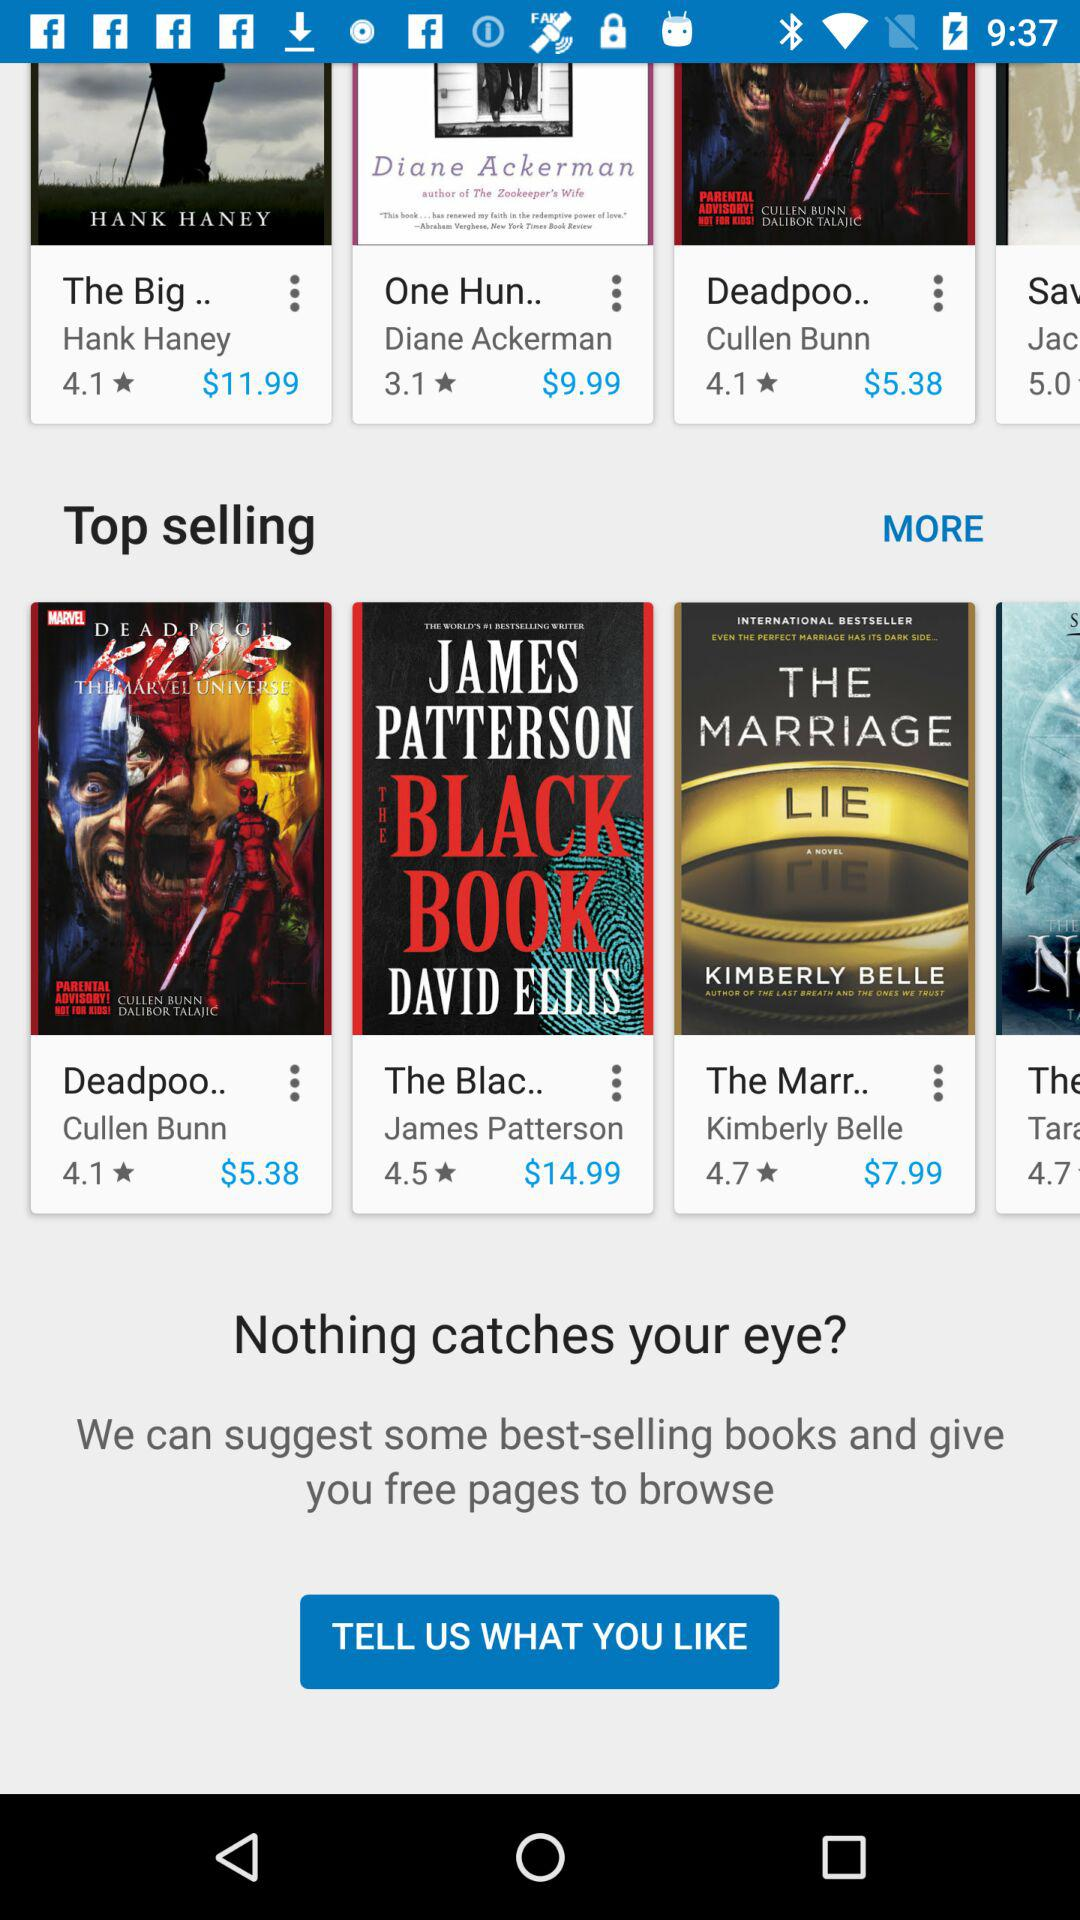What is the star rating of the book "The Black Book"? The star rating of the book "The Black Book" is 4.5. 